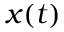<formula> <loc_0><loc_0><loc_500><loc_500>x ( t )</formula> 